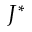<formula> <loc_0><loc_0><loc_500><loc_500>J ^ { \ast }</formula> 